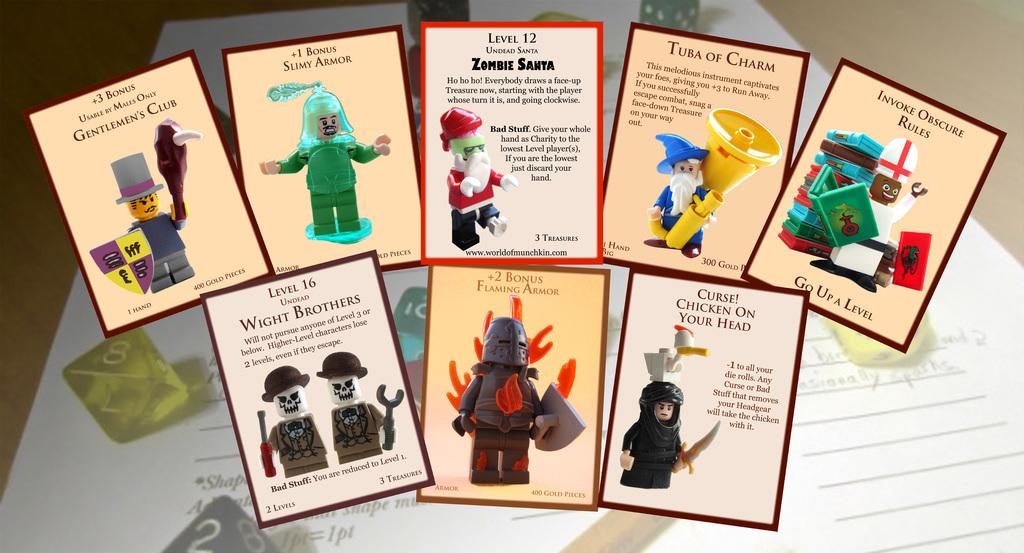<image>
Relay a brief, clear account of the picture shown. Several cards feature Lego characters, including Level 12, Zombie Santa. 